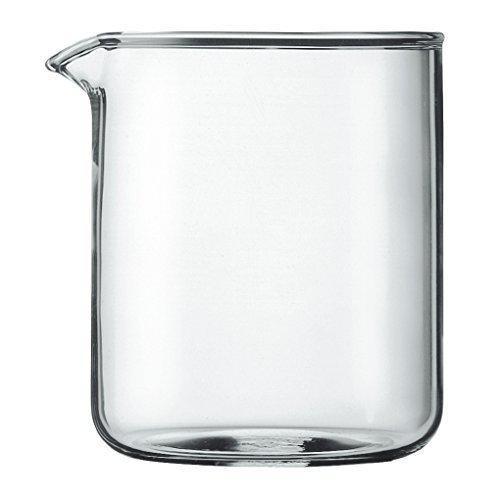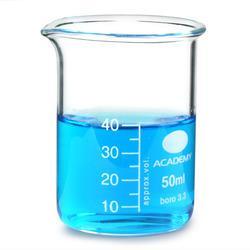The first image is the image on the left, the second image is the image on the right. Examine the images to the left and right. Is the description "The left and right image contains the same number of beakers." accurate? Answer yes or no. Yes. The first image is the image on the left, the second image is the image on the right. For the images displayed, is the sentence "The right image includes a cylindrical container of blue liquid, and the left image features exactly one container." factually correct? Answer yes or no. Yes. 